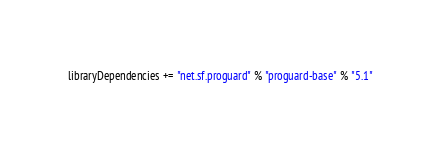<code> <loc_0><loc_0><loc_500><loc_500><_Scala_>libraryDependencies += "net.sf.proguard" % "proguard-base" % "5.1"
</code> 